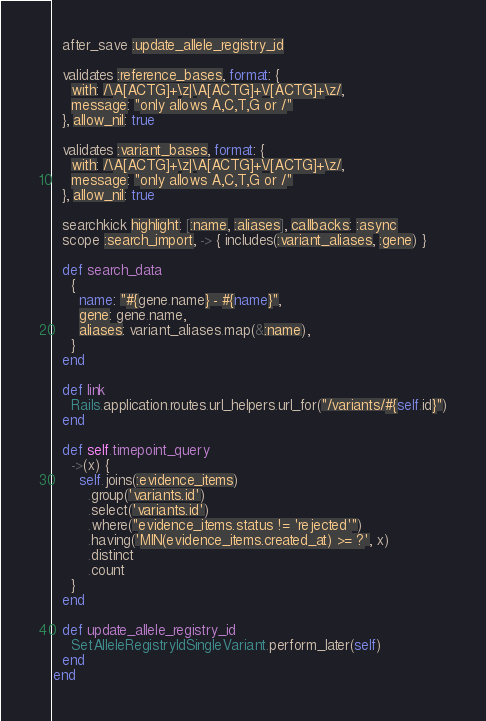Convert code to text. <code><loc_0><loc_0><loc_500><loc_500><_Ruby_>  after_save :update_allele_registry_id

  validates :reference_bases, format: {
    with: /\A[ACTG]+\z|\A[ACTG]+\/[ACTG]+\z/,
    message: "only allows A,C,T,G or /"
  }, allow_nil: true

  validates :variant_bases, format: {
    with: /\A[ACTG]+\z|\A[ACTG]+\/[ACTG]+\z/,
    message: "only allows A,C,T,G or /"
  }, allow_nil: true

  searchkick highlight: [:name, :aliases], callbacks: :async
  scope :search_import, -> { includes(:variant_aliases, :gene) }

  def search_data
    {
      name: "#{gene.name} - #{name}",
      gene: gene.name,
      aliases: variant_aliases.map(&:name),
    }
  end

  def link
    Rails.application.routes.url_helpers.url_for("/variants/#{self.id}")
  end

  def self.timepoint_query
    ->(x) {
      self.joins(:evidence_items)
        .group('variants.id')
        .select('variants.id')
        .where("evidence_items.status != 'rejected'")
        .having('MIN(evidence_items.created_at) >= ?', x)
        .distinct
        .count
    }
  end

  def update_allele_registry_id
    SetAlleleRegistryIdSingleVariant.perform_later(self)
  end
end
</code> 